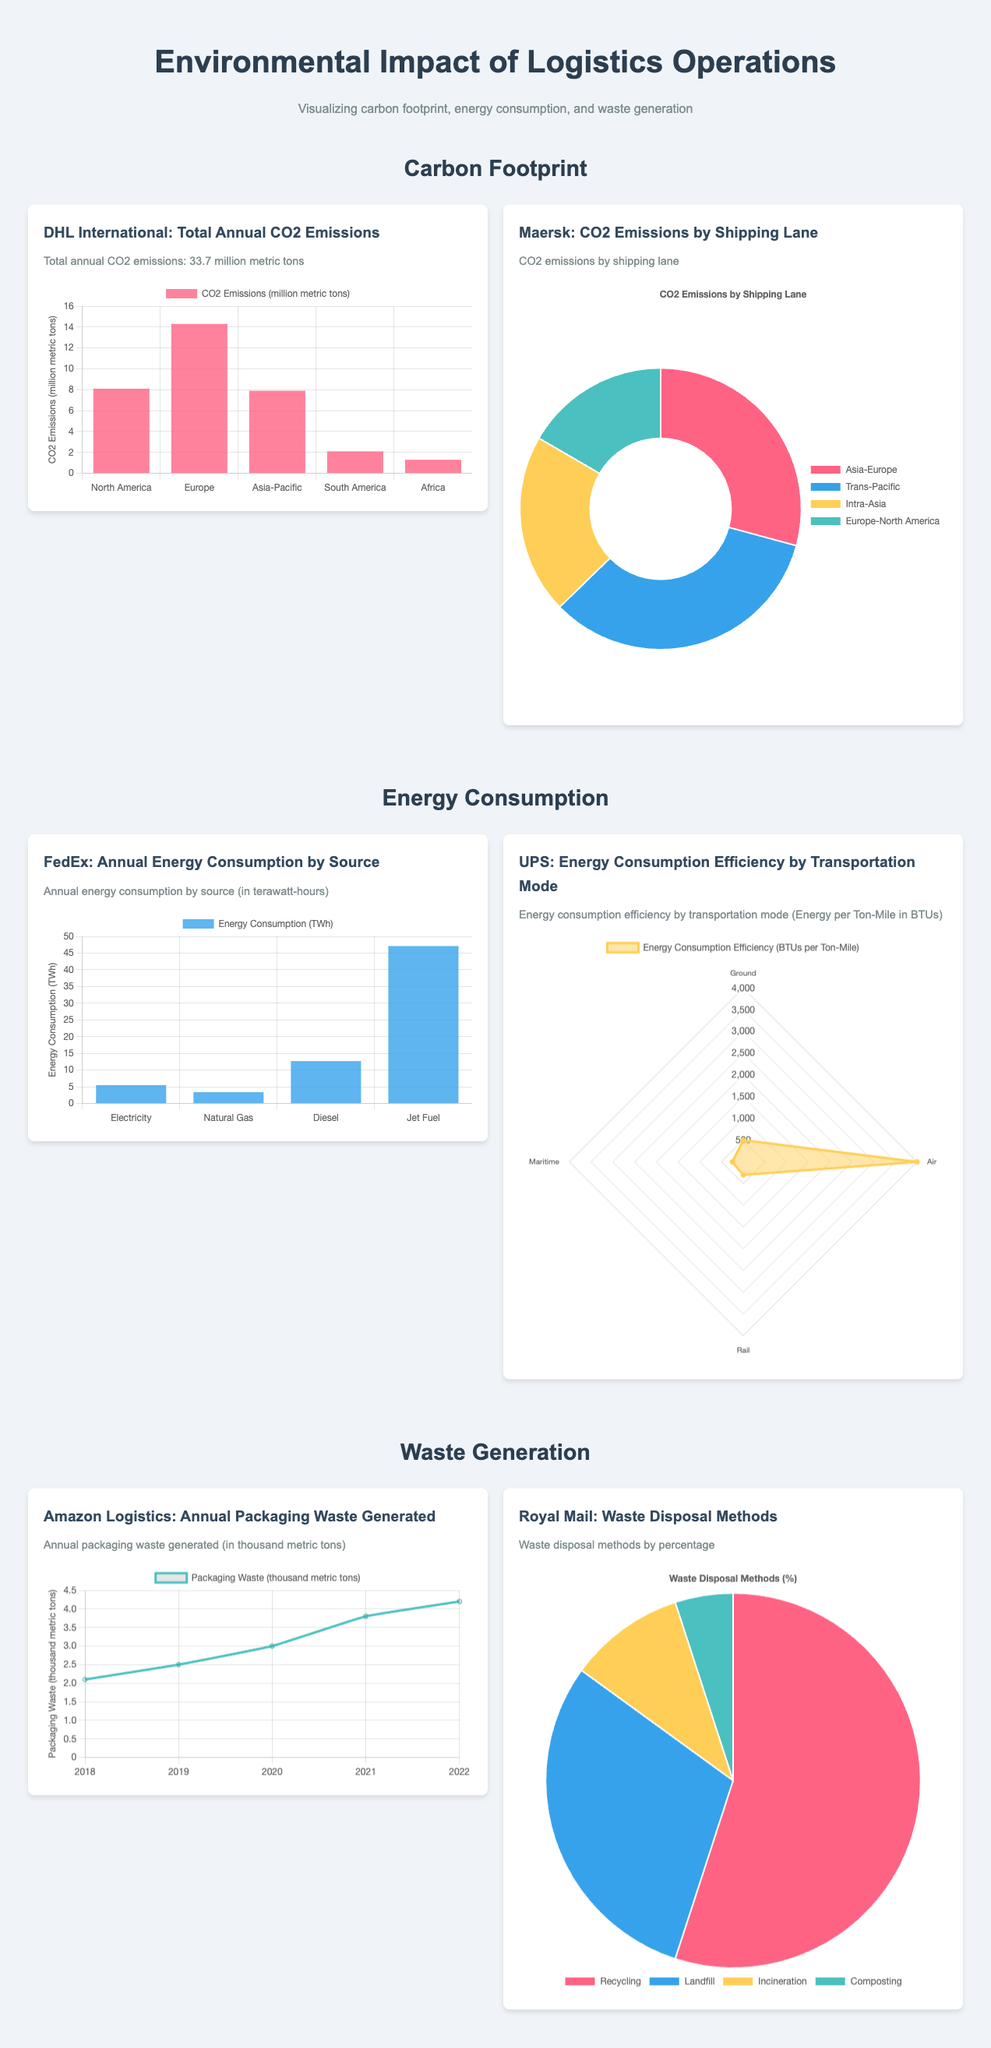What is the total annual CO2 emissions for DHL International? The total annual CO2 emissions for DHL International is stated in the document as 33.7 million metric tons.
Answer: 33.7 million metric tons What is the primary energy source contributing to FedEx's consumption? The primary energy source contributing to FedEx's consumption can be found in the chart displaying annual energy consumption by source, which identifies Jet Fuel as having the highest consumption.
Answer: Jet Fuel What is the percentage of Royal Mail's waste disposal through recycling? The document indicates that Royal Mail disposes of 55% of its waste through recycling as shown in the pie chart.
Answer: 55% In which year did Amazon Logistics display the highest packaging waste generated? The line chart shows the packaging waste data over the years, highlighting that 2022 had the highest annual packaging waste generated.
Answer: 2022 Which transportation mode has the lowest energy consumption efficiency in UPS's chart? The UPS energy consumption efficiency chart presents data for multiple modes, where Ground has the lowest consumption efficiency.
Answer: Ground Which shipping lane has the highest CO2 emissions according to Maersk's chart? The doughnut chart for Maersk indicates that the Trans-Pacific lane has the highest CO2 emissions.
Answer: Trans-Pacific What type of visualization is used to represent FedEx's annual energy consumption? The document specifies that FedEx's annual energy consumption is represented using a bar chart.
Answer: Bar chart How much packaging waste did Amazon generate in 2020? The data displayed in the line chart indicates that Amazon generated 3.0 thousand metric tons of packaging waste in 2020.
Answer: 3.0 thousand metric tons What visualization type is employed for Royal Mail's waste disposal methods? The pie chart employed for Royal Mail presents waste disposal methods by percentage.
Answer: Pie chart 